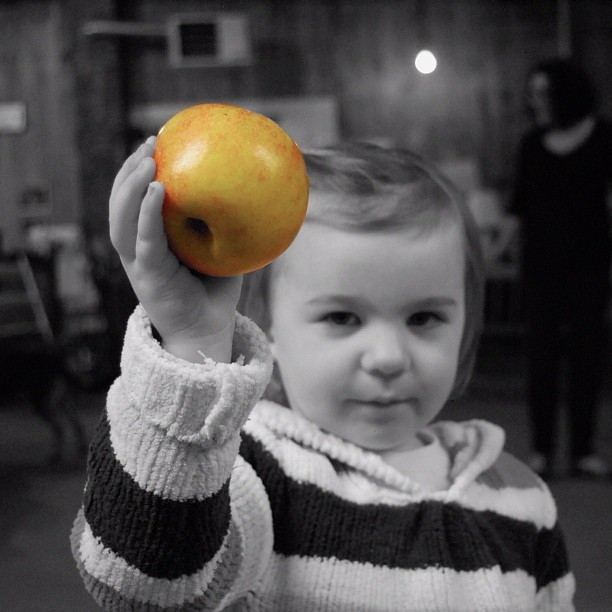Describe the objects in this image and their specific colors. I can see people in black, darkgray, gray, and lightgray tones, people in black tones, apple in black, tan, olive, and maroon tones, chair in black and lightgray tones, and microwave in black and gray tones in this image. 